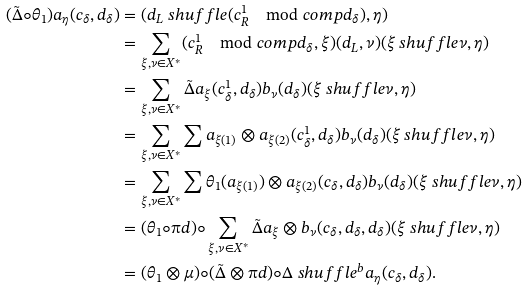Convert formula to latex. <formula><loc_0><loc_0><loc_500><loc_500>( \tilde { \Delta } \circ \theta _ { 1 } ) a _ { \eta } ( c _ { \delta } , d _ { \delta } ) & = ( d _ { L } \ s h u f f l e ( c _ { R } ^ { 1 } \mod c o m p d _ { \delta } ) , \eta ) \\ & = \sum _ { \xi , \nu \in X ^ { \ast } } ( c _ { R } ^ { 1 } \mod c o m p d _ { \delta } , \xi ) ( d _ { L } , \nu ) ( \xi \ s h u f f l e \nu , \eta ) \\ & = \sum _ { \xi , \nu \in X ^ { \ast } } \tilde { \Delta } a _ { \xi } ( c _ { \delta } ^ { 1 } , d _ { \delta } ) b _ { \nu } ( d _ { \delta } ) ( \xi \ s h u f f l e \nu , \eta ) \\ & = \sum _ { \xi , \nu \in X ^ { \ast } } \sum a _ { \xi ( 1 ) } \otimes a _ { \xi ( 2 ) } ( c _ { \delta } ^ { 1 } , d _ { \delta } ) b _ { \nu } ( d _ { \delta } ) ( \xi \ s h u f f l e \nu , \eta ) \\ & = \sum _ { \xi , \nu \in X ^ { \ast } } \sum \theta _ { 1 } ( a _ { \xi ( 1 ) } ) \otimes a _ { \xi ( 2 ) } ( c _ { \delta } , d _ { \delta } ) b _ { \nu } ( d _ { \delta } ) ( \xi \ s h u f f l e \nu , \eta ) \\ & = ( \theta _ { 1 } \circ \i d ) \circ \sum _ { \xi , \nu \in X ^ { \ast } } \tilde { \Delta } a _ { \xi } \otimes b _ { \nu } ( c _ { \delta } , d _ { \delta } , d _ { \delta } ) ( \xi \ s h u f f l e \nu , \eta ) \\ & = ( \theta _ { 1 } \otimes \mu ) \circ ( \tilde { \Delta } \otimes \i d ) \circ \Delta _ { \ } s h u f f l e ^ { b } a _ { \eta } ( c _ { \delta } , d _ { \delta } ) .</formula> 